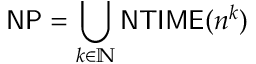Convert formula to latex. <formula><loc_0><loc_0><loc_500><loc_500>{ N P } = \bigcup _ { k \in \mathbb { N } } { N T I M E } ( n ^ { k } )</formula> 